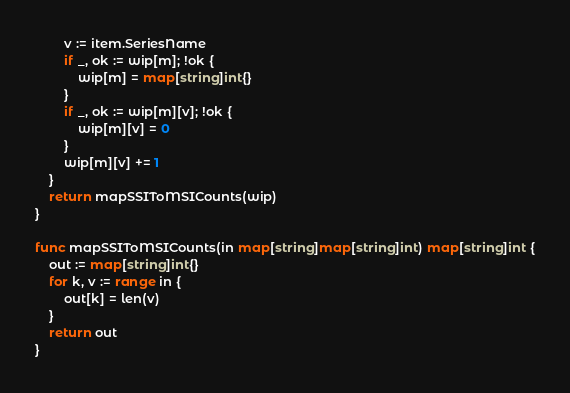<code> <loc_0><loc_0><loc_500><loc_500><_Go_>		v := item.SeriesName
		if _, ok := wip[m]; !ok {
			wip[m] = map[string]int{}
		}
		if _, ok := wip[m][v]; !ok {
			wip[m][v] = 0
		}
		wip[m][v] += 1
	}
	return mapSSIToMSICounts(wip)
}

func mapSSIToMSICounts(in map[string]map[string]int) map[string]int {
	out := map[string]int{}
	for k, v := range in {
		out[k] = len(v)
	}
	return out
}
</code> 